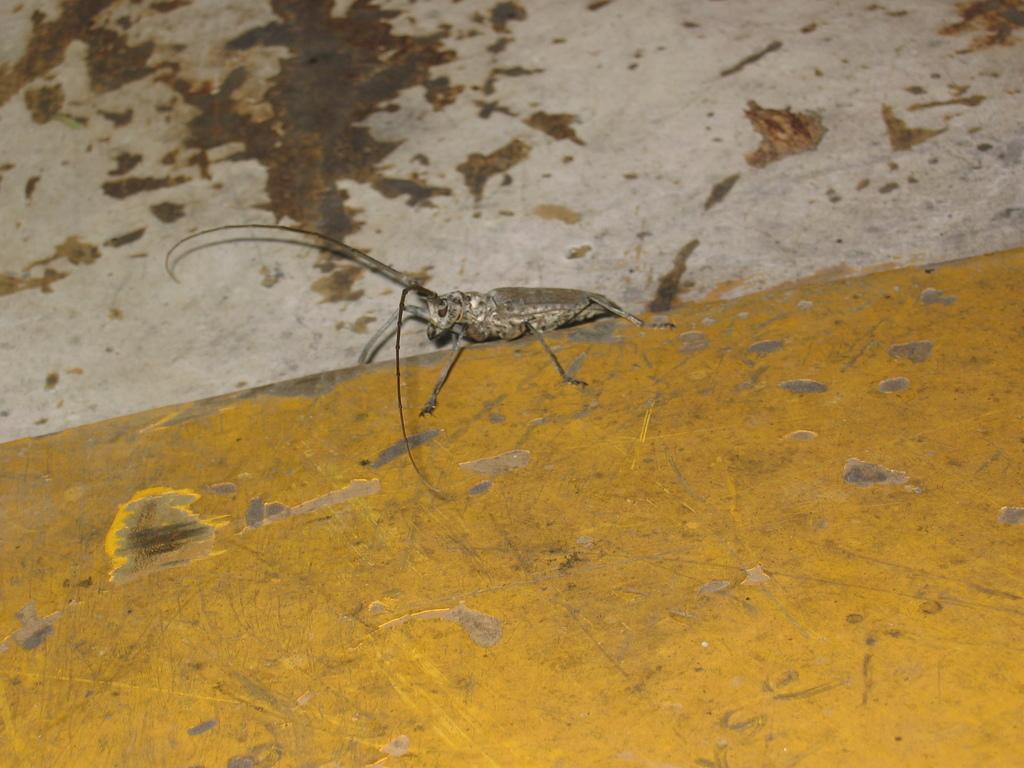Can you describe this image briefly? In the image there is an insect standing on the wall. 